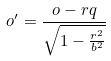<formula> <loc_0><loc_0><loc_500><loc_500>o ^ { \prime } = \frac { o - r q } { \sqrt { 1 - \frac { r ^ { 2 } } { b ^ { 2 } } } }</formula> 